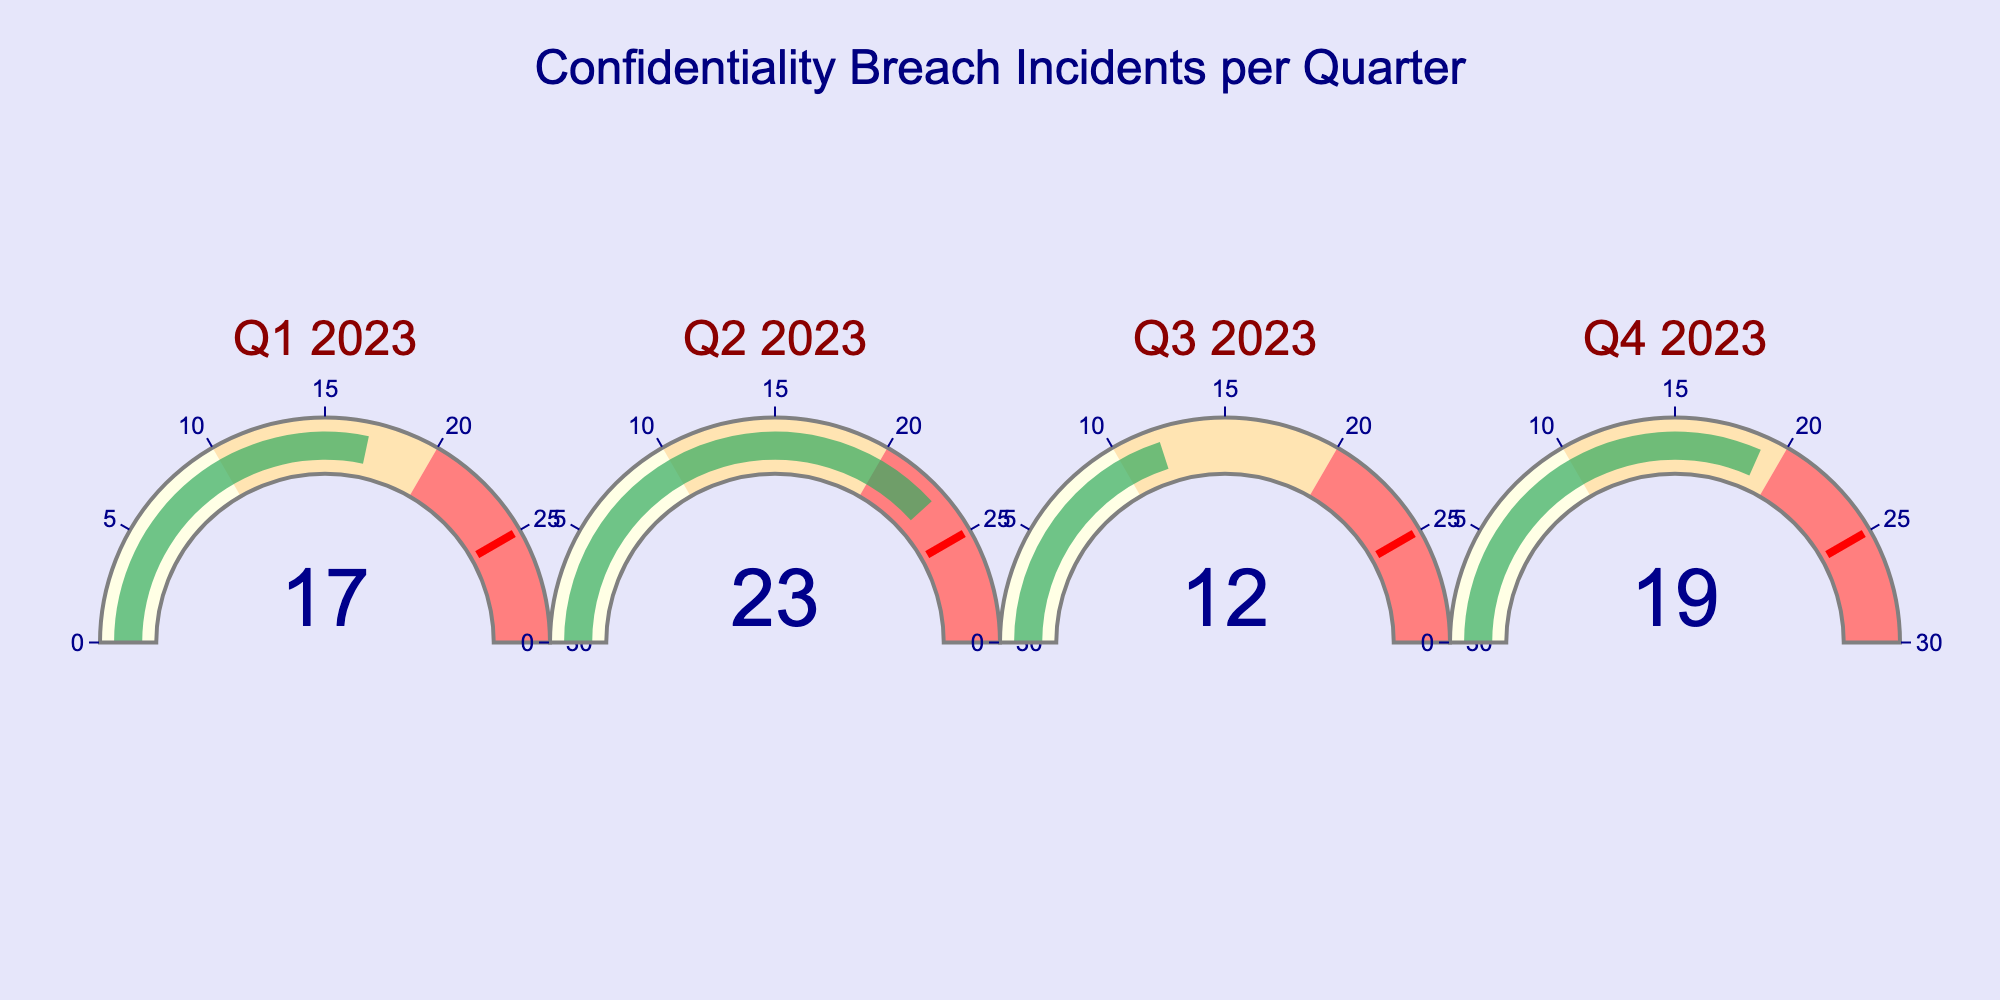What's the title of the figure? The title is typically found at the top center of the chart. It summarizes the main subject of the figure.
Answer: Confidentiality Breach Incidents per Quarter How many quarters are depicted in the figure? Each gauge in the figure represents a quarter. By counting the gauges, we can determine the number of quarters represented.
Answer: 4 Which quarter had the highest number of confidentiality breaches? By comparing the numbers on each gauge, we can identify the highest value.
Answer: Q2 2023 What is the range of the gauge charts? The range of the gauge charts can be seen on their axis, which indicates the span of values covered.
Answer: 0 to 30 What is the threshold value marked by the red line on each gauge? The threshold line is a distinct feature on the gauge chart, and its value is indicated explicitly.
Answer: 25 How many breaches were recorded in Q3 2023? The number of breaches in each quarter is displayed within the gauge.
Answer: 12 What is the sum of breaches in Q1 2023 and Q4 2023? To find the sum, add the number of breaches in Q1 2023 (17) and Q4 2023 (19).
Answer: 36 Which quarter had fewer breaches, Q1 2023 or Q4 2023? To compare, look at the values for Q1 2023 (17) and Q4 2023 (19) and determine which is smaller.
Answer: Q1 2023 What's the range of breach incidents considered to be at high risk, represented by the red color? The range for different risk levels is indicated by different colors on the gauge. High risk is represented by the reddish color.
Answer: 20 to 30 Looking at the overall figure, did any quarter meet or exceed the threshold value? Check each quarter against the threshold value of 25 to determine if any values meet or exceed it.
Answer: No 